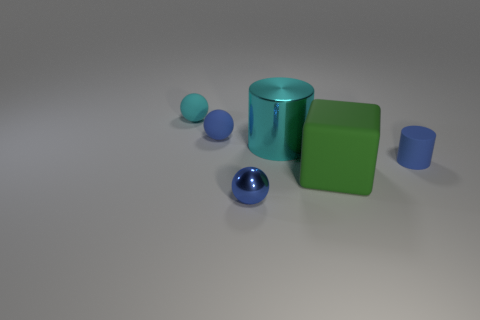Subtract all cyan spheres. How many spheres are left? 2 Add 1 rubber blocks. How many objects exist? 7 Subtract all cylinders. How many objects are left? 4 Add 4 small blue metal things. How many small blue metal things are left? 5 Add 3 large green rubber cubes. How many large green rubber cubes exist? 4 Subtract 0 gray balls. How many objects are left? 6 Subtract all purple rubber objects. Subtract all blue shiny balls. How many objects are left? 5 